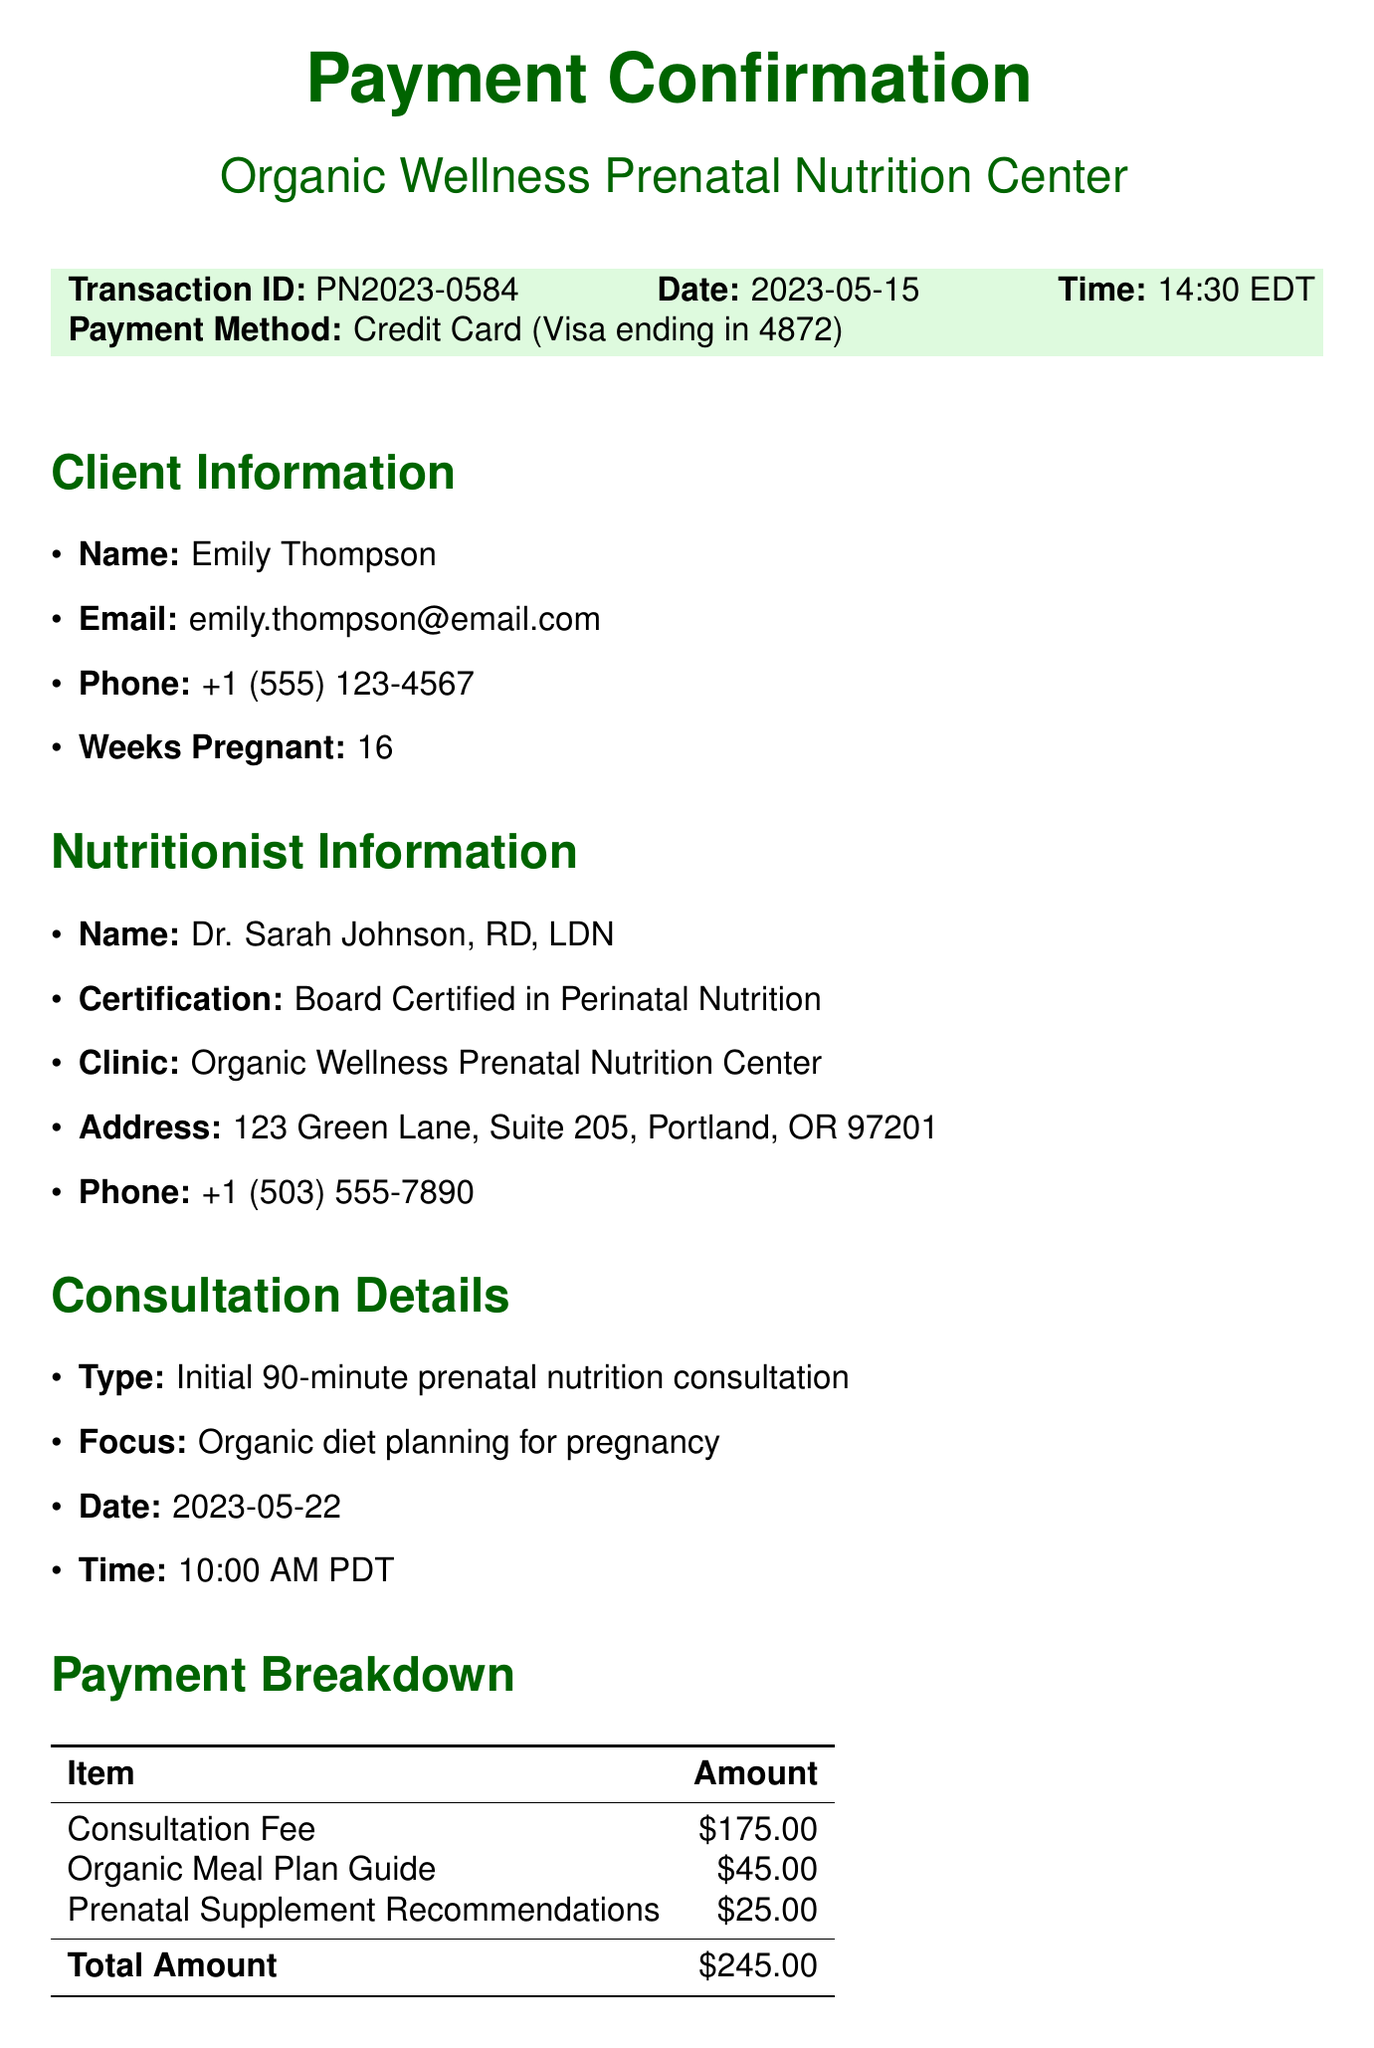what is the transaction ID? The transaction ID is specified in the document under transaction details.
Answer: PN2023-0584 who is the nutritionist? The nutritionist's name is provided in the nutritionist information section of the document.
Answer: Dr. Sarah Johnson, RD, LDN what is the total amount paid? The total amount is highlighted in the payment breakdown section of the document.
Answer: $245.00 when is the consultation date? The consultation date is specified in the consultation details section of the document.
Answer: 2023-05-22 what is the cancellation policy? The cancellation policy is summarized in a dedicated section of the document, outlining the notice required and fee.
Answer: 48 hours notice required. Fee: 50% of consultation cost how long is the consultation session? The duration of the consultation session is mentioned in the consultation details section.
Answer: 90 minutes what is included in the organic meal plan guide fee? This fee is listed under the payment breakdown and specifies an additional service provided.
Answer: Organic Meal Plan Guide what is the focus of the consultation? The focus is noted in the consultation details, describing the primary aim of the session.
Answer: Organic diet planning for pregnancy is the payment status approved? The payment status is clearly listed in the payment confirmation section of the document.
Answer: Approved 